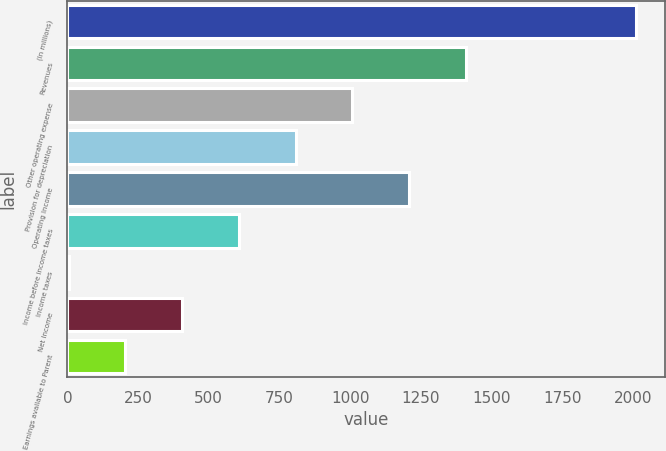Convert chart. <chart><loc_0><loc_0><loc_500><loc_500><bar_chart><fcel>(In millions)<fcel>Revenues<fcel>Other operating expense<fcel>Provision for depreciation<fcel>Operating Income<fcel>Income before income taxes<fcel>Income taxes<fcel>Net Income<fcel>Earnings available to Parent<nl><fcel>2011<fcel>1409.02<fcel>1007.7<fcel>807.04<fcel>1208.36<fcel>606.38<fcel>4.4<fcel>405.72<fcel>205.06<nl></chart> 